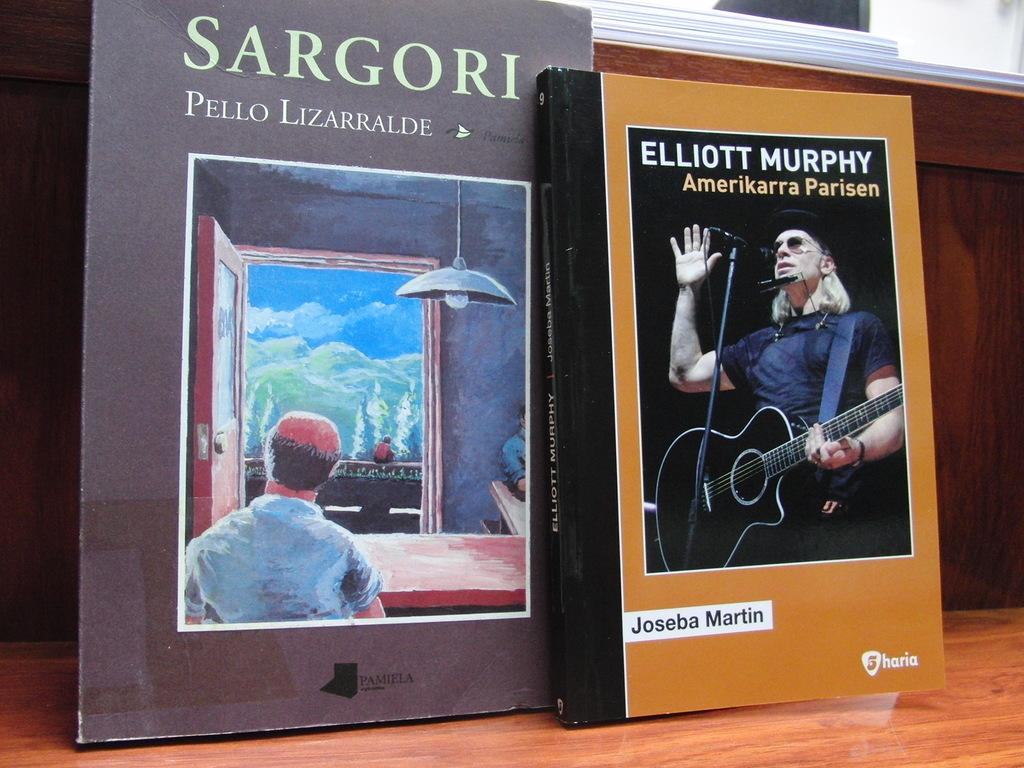What is the person in the image doing? The person is playing a guitar. What object is the person using to perform this activity? The person is using a guitar. What other object can be seen in the image? There is a table in the image. What is on the table? There is a book on the table. Is the person in the image a spy, and what is their relation to the book on the table? There is no indication in the image that the person is a spy, and their relation to the book on the table cannot be determined from the image. 